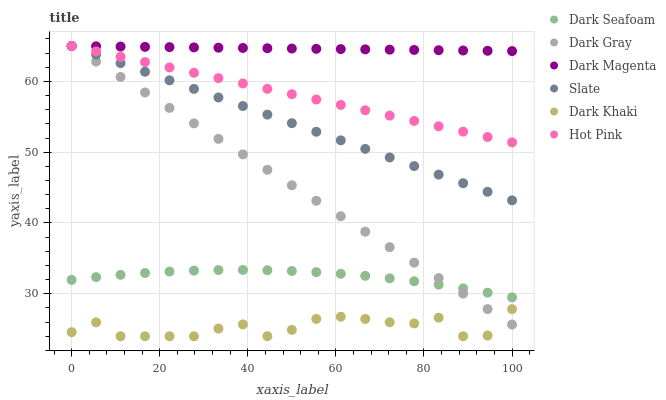Does Dark Khaki have the minimum area under the curve?
Answer yes or no. Yes. Does Dark Magenta have the maximum area under the curve?
Answer yes or no. Yes. Does Slate have the minimum area under the curve?
Answer yes or no. No. Does Slate have the maximum area under the curve?
Answer yes or no. No. Is Dark Magenta the smoothest?
Answer yes or no. Yes. Is Dark Khaki the roughest?
Answer yes or no. Yes. Is Slate the smoothest?
Answer yes or no. No. Is Slate the roughest?
Answer yes or no. No. Does Dark Khaki have the lowest value?
Answer yes or no. Yes. Does Slate have the lowest value?
Answer yes or no. No. Does Dark Gray have the highest value?
Answer yes or no. Yes. Does Dark Seafoam have the highest value?
Answer yes or no. No. Is Dark Seafoam less than Dark Magenta?
Answer yes or no. Yes. Is Dark Seafoam greater than Dark Khaki?
Answer yes or no. Yes. Does Dark Magenta intersect Hot Pink?
Answer yes or no. Yes. Is Dark Magenta less than Hot Pink?
Answer yes or no. No. Is Dark Magenta greater than Hot Pink?
Answer yes or no. No. Does Dark Seafoam intersect Dark Magenta?
Answer yes or no. No. 